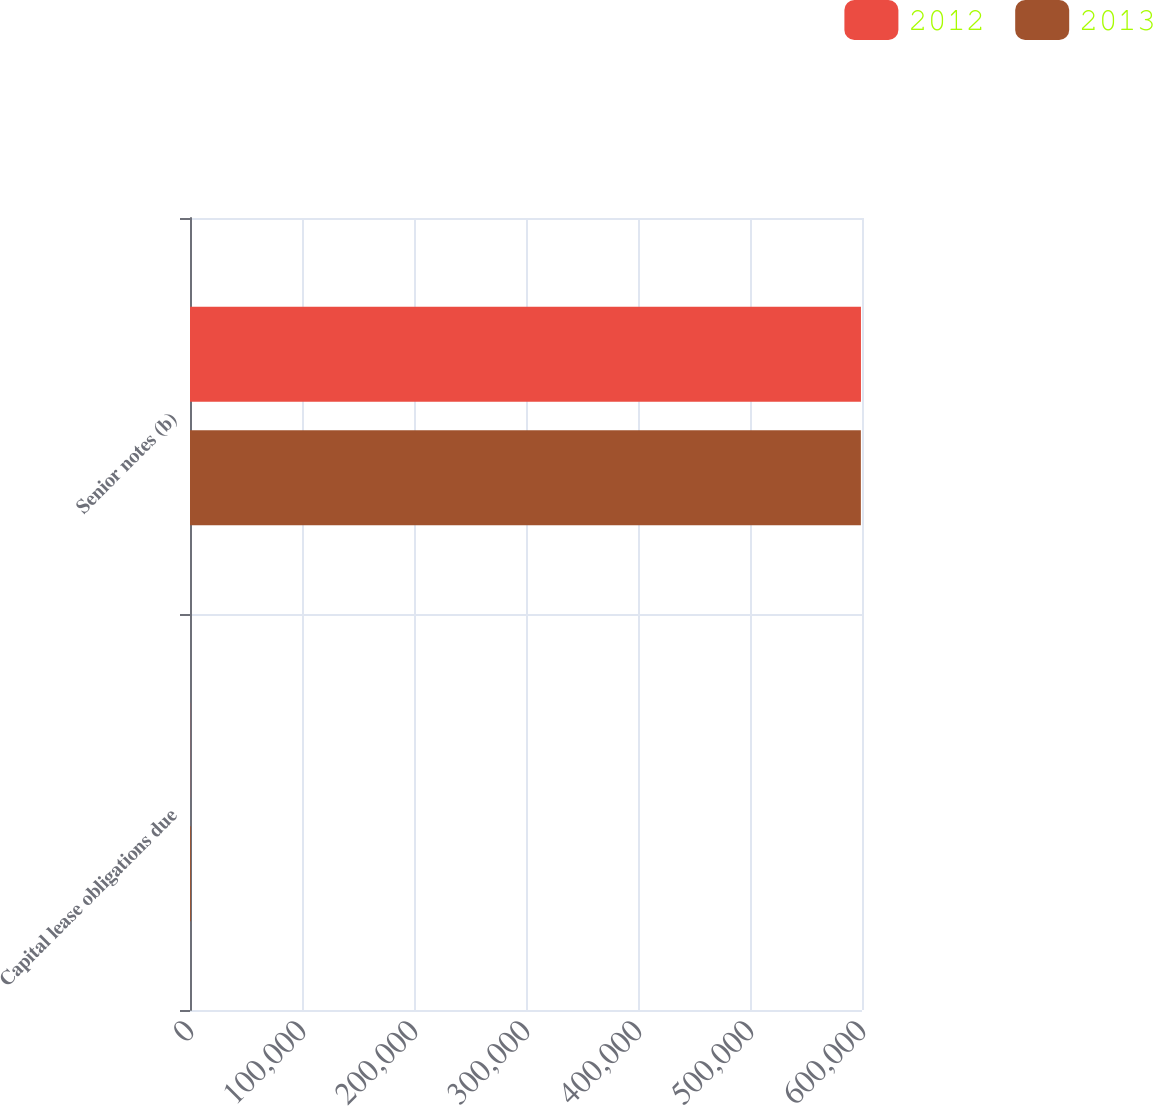Convert chart. <chart><loc_0><loc_0><loc_500><loc_500><stacked_bar_chart><ecel><fcel>Capital lease obligations due<fcel>Senior notes (b)<nl><fcel>2012<fcel>115<fcel>599075<nl><fcel>2013<fcel>757<fcel>598988<nl></chart> 